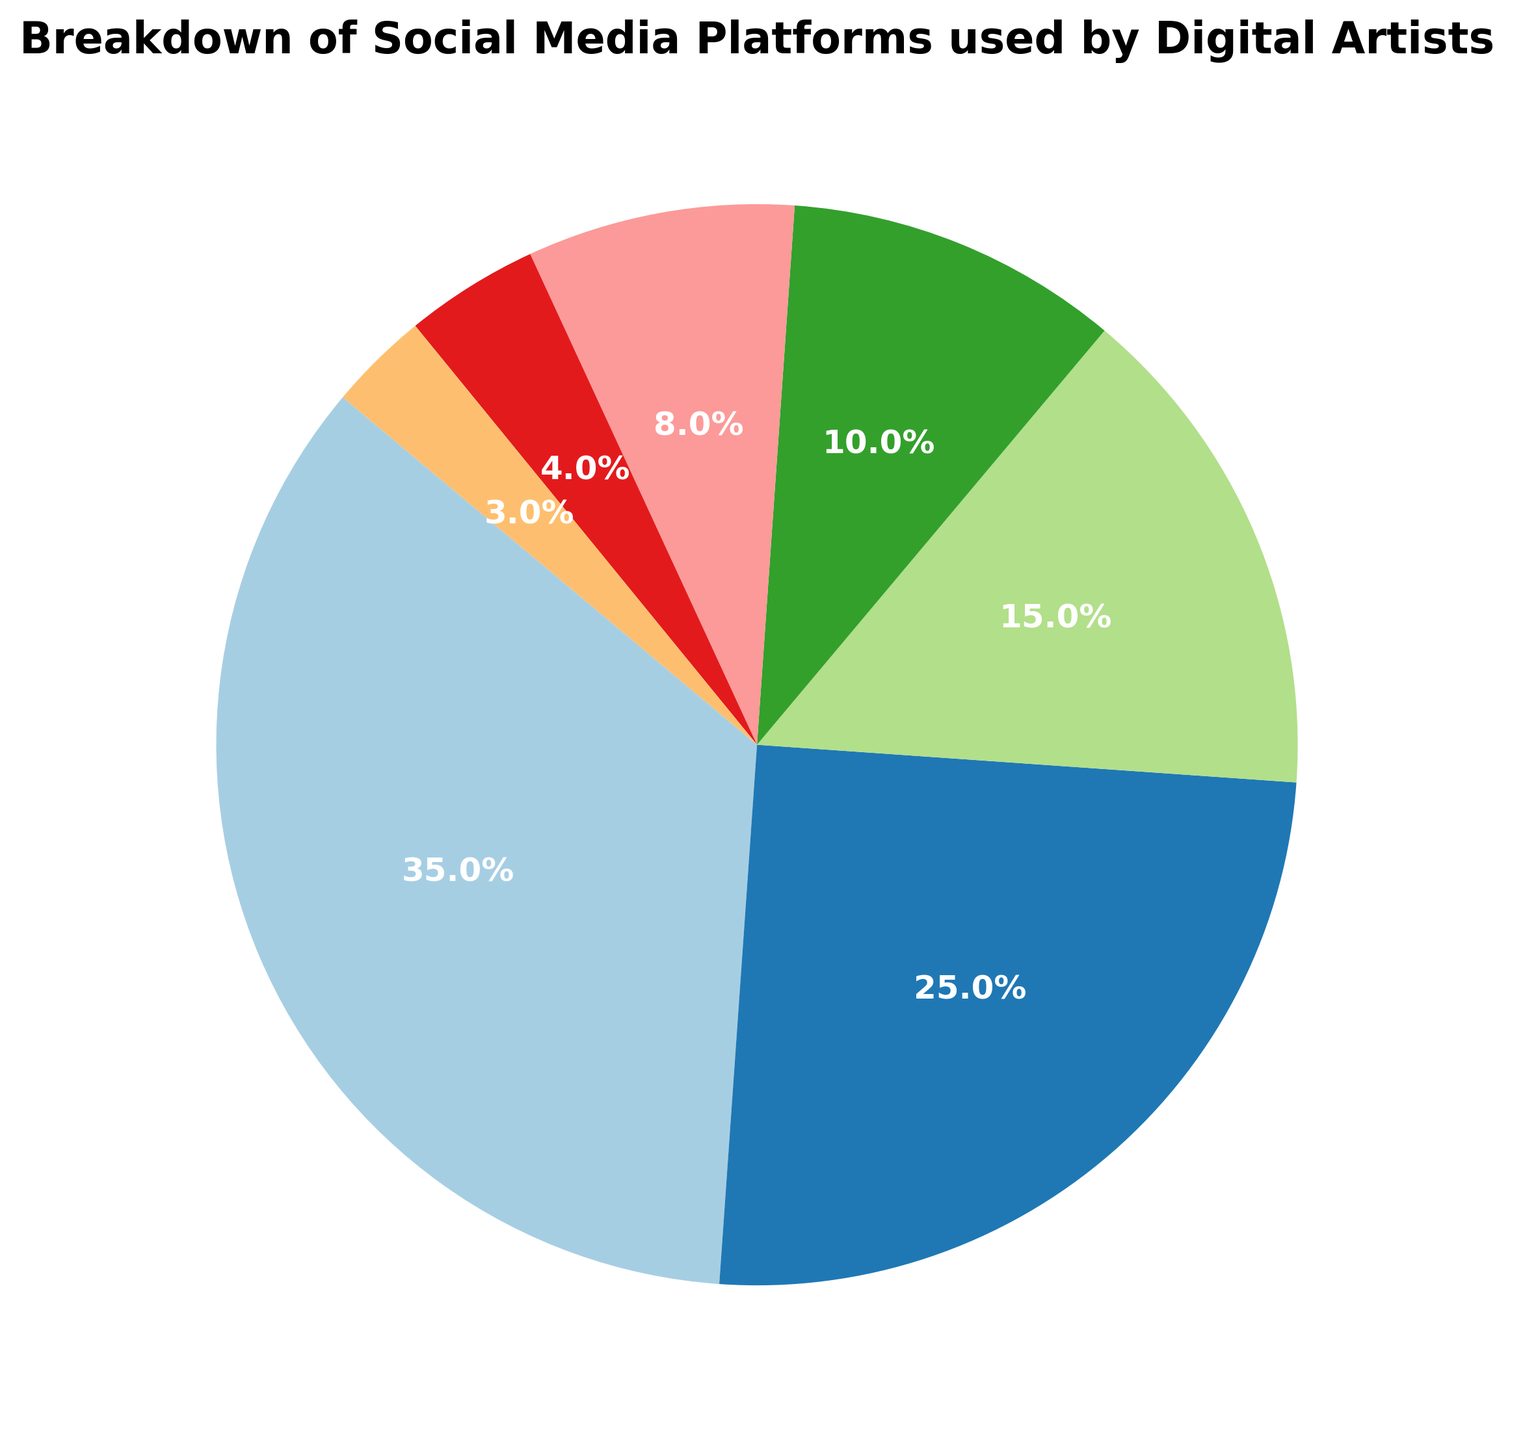Which platform has the largest share among digital artists? The largest share can be identified by looking at the platform with the highest percentage, which is represented by the largest segment in the pie chart. By comparing all segments, we find that Instagram has the largest share with 35%.
Answer: Instagram What is the total percentage of digital artists using either Instagram or ArtStation? To find the total percentage, we add the percentages of Instagram and ArtStation from the chart. Instagram accounts for 35%, and ArtStation accounts for 25%. So, 35% + 25% = 60%.
Answer: 60% Which platform is used less, Facebook or Pinterest? To determine which platform is used less, we compare the percentages of Facebook and Pinterest from the pie chart. Facebook has 8%, while Pinterest has 4%. Pinterest is used less.
Answer: Pinterest How much more popular is Instagram compared to DeviantArt? To find out how much more popular Instagram is compared to DeviantArt, we subtract DeviantArt's percentage from Instagram's. Instagram has 35%, and DeviantArt has 15%. So, 35% - 15% = 20%.
Answer: 20% Which platforms collectively constitute exactly half of the total usage? By adding percentages, we find out which combination of platforms equals 50%. Adding Instagram (35%) and ArtStation (25%) exceeds 50%, but combining Instagram (35%) with DeviantArt (15%) achieves 50%. So, Instagram and DeviantArt collectively make up half of the total usage.
Answer: Instagram and DeviantArt What is the combined share of platforms with a smaller percentage than Twitter? To find this, we sum the percentages of platforms with less than Twitter's 10%. Pinterest has 4%, and Behance has 3%, so 4% + 3% = 7%.
Answer: 7% Which platform's segment is represented by the darkest color in the pie chart? The darkest color in the pie chart visually identifies the platform, which requires looking at the color gradient and matching the darkest segment to its label.
Answer: DeviantArt (assuming visually darker) Are there more digital artists using Twitter or Facebook to share their work? By comparing the percentages from the pie chart, Twitter has 10%, while Facebook has 8%. Therefore, more digital artists use Twitter.
Answer: Twitter 